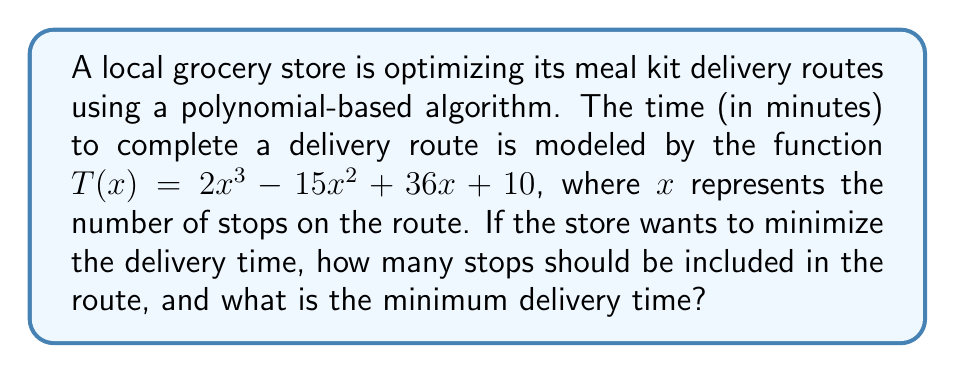Solve this math problem. To find the minimum delivery time, we need to find the minimum point of the function $T(x)$. This can be done by following these steps:

1) First, we need to find the derivative of $T(x)$:
   $T'(x) = 6x^2 - 30x + 36$

2) To find the critical points, set $T'(x) = 0$:
   $6x^2 - 30x + 36 = 0$

3) This is a quadratic equation. We can solve it using the quadratic formula:
   $x = \frac{-b \pm \sqrt{b^2 - 4ac}}{2a}$

   Where $a = 6$, $b = -30$, and $c = 36$

4) Plugging in these values:
   $x = \frac{30 \pm \sqrt{(-30)^2 - 4(6)(36)}}{2(6)}$
   $= \frac{30 \pm \sqrt{900 - 864}}{12}$
   $= \frac{30 \pm \sqrt{36}}{12}$
   $= \frac{30 \pm 6}{12}$

5) This gives us two critical points:
   $x_1 = \frac{30 + 6}{12} = 3$
   $x_2 = \frac{30 - 6}{12} = 2$

6) To determine which point gives the minimum, we can use the second derivative test:
   $T''(x) = 12x - 30$

   At $x = 3$: $T''(3) = 12(3) - 30 = 6 > 0$, so this is a local minimum.
   At $x = 2$: $T''(2) = 12(2) - 30 = -6 < 0$, so this is a local maximum.

7) Therefore, the minimum occurs at $x = 3$ stops.

8) To find the minimum time, we plug $x = 3$ into the original function:
   $T(3) = 2(3)^3 - 15(3)^2 + 36(3) + 10$
   $= 54 - 135 + 108 + 10$
   $= 37$

Thus, the minimum delivery time is 37 minutes.
Answer: The optimal route should include 3 stops, and the minimum delivery time is 37 minutes. 